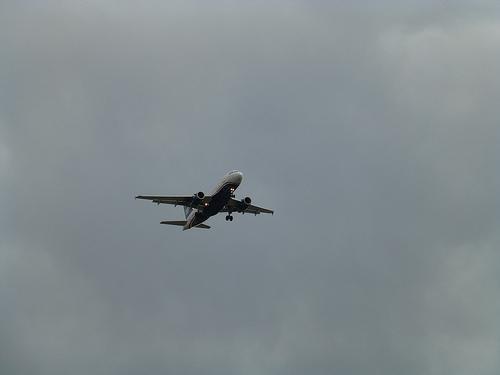How many airplanes?
Give a very brief answer. 1. 